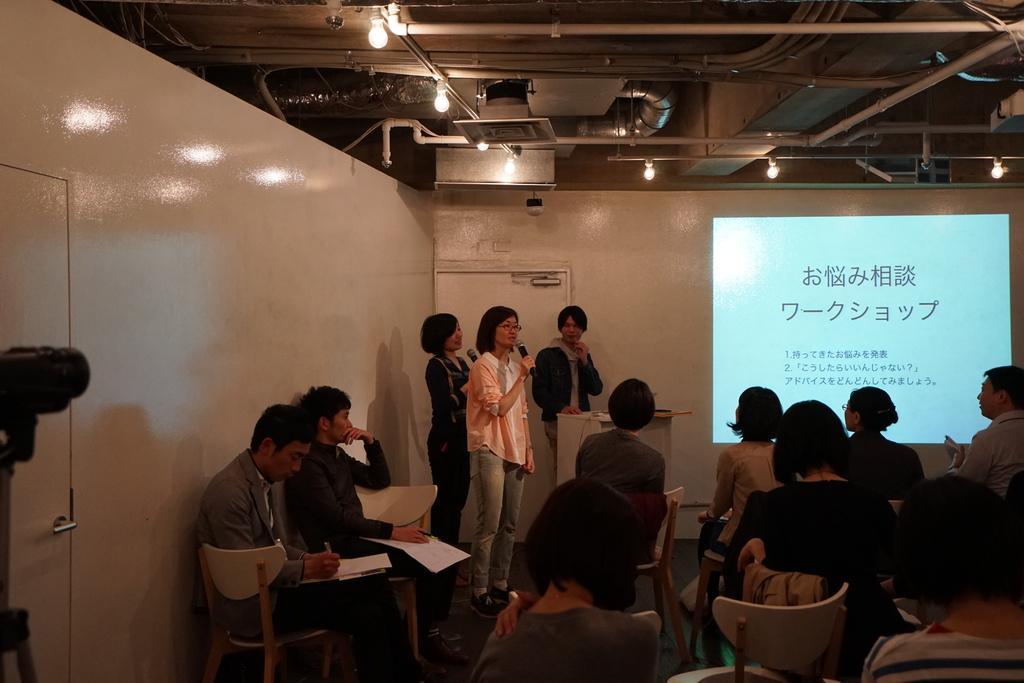In one or two sentences, can you explain what this image depicts? In this image I see number of people in which most of them are sitting on chairs and I see that these both women are holding mics and these 3 of them are standing and I see the wall. Over here I see the white screen on which there are words written and I see the lights and few equipment over here and I see the door over here. 